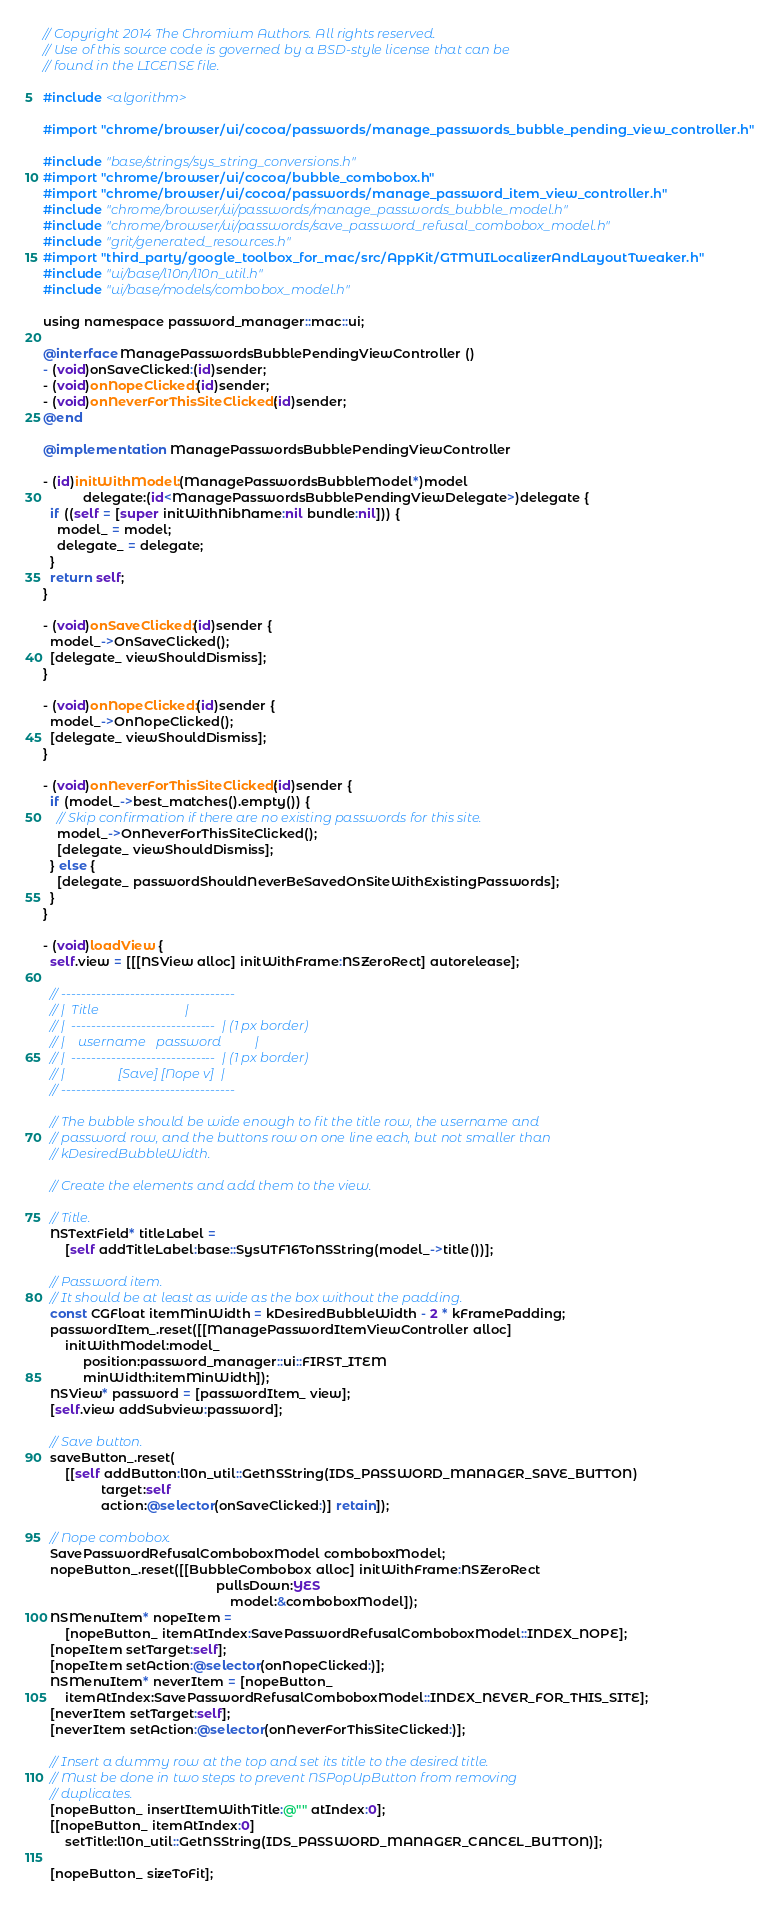<code> <loc_0><loc_0><loc_500><loc_500><_ObjectiveC_>// Copyright 2014 The Chromium Authors. All rights reserved.
// Use of this source code is governed by a BSD-style license that can be
// found in the LICENSE file.

#include <algorithm>

#import "chrome/browser/ui/cocoa/passwords/manage_passwords_bubble_pending_view_controller.h"

#include "base/strings/sys_string_conversions.h"
#import "chrome/browser/ui/cocoa/bubble_combobox.h"
#import "chrome/browser/ui/cocoa/passwords/manage_password_item_view_controller.h"
#include "chrome/browser/ui/passwords/manage_passwords_bubble_model.h"
#include "chrome/browser/ui/passwords/save_password_refusal_combobox_model.h"
#include "grit/generated_resources.h"
#import "third_party/google_toolbox_for_mac/src/AppKit/GTMUILocalizerAndLayoutTweaker.h"
#include "ui/base/l10n/l10n_util.h"
#include "ui/base/models/combobox_model.h"

using namespace password_manager::mac::ui;

@interface ManagePasswordsBubblePendingViewController ()
- (void)onSaveClicked:(id)sender;
- (void)onNopeClicked:(id)sender;
- (void)onNeverForThisSiteClicked:(id)sender;
@end

@implementation ManagePasswordsBubblePendingViewController

- (id)initWithModel:(ManagePasswordsBubbleModel*)model
           delegate:(id<ManagePasswordsBubblePendingViewDelegate>)delegate {
  if ((self = [super initWithNibName:nil bundle:nil])) {
    model_ = model;
    delegate_ = delegate;
  }
  return self;
}

- (void)onSaveClicked:(id)sender {
  model_->OnSaveClicked();
  [delegate_ viewShouldDismiss];
}

- (void)onNopeClicked:(id)sender {
  model_->OnNopeClicked();
  [delegate_ viewShouldDismiss];
}

- (void)onNeverForThisSiteClicked:(id)sender {
  if (model_->best_matches().empty()) {
    // Skip confirmation if there are no existing passwords for this site.
    model_->OnNeverForThisSiteClicked();
    [delegate_ viewShouldDismiss];
  } else {
    [delegate_ passwordShouldNeverBeSavedOnSiteWithExistingPasswords];
  }
}

- (void)loadView {
  self.view = [[[NSView alloc] initWithFrame:NSZeroRect] autorelease];

  // -----------------------------------
  // |  Title                          |
  // |  -----------------------------  | (1 px border)
  // |    username   password          |
  // |  -----------------------------  | (1 px border)
  // |                [Save] [Nope v]  |
  // -----------------------------------

  // The bubble should be wide enough to fit the title row, the username and
  // password row, and the buttons row on one line each, but not smaller than
  // kDesiredBubbleWidth.

  // Create the elements and add them to the view.

  // Title.
  NSTextField* titleLabel =
      [self addTitleLabel:base::SysUTF16ToNSString(model_->title())];

  // Password item.
  // It should be at least as wide as the box without the padding.
  const CGFloat itemMinWidth = kDesiredBubbleWidth - 2 * kFramePadding;
  passwordItem_.reset([[ManagePasswordItemViewController alloc]
      initWithModel:model_
           position:password_manager::ui::FIRST_ITEM
           minWidth:itemMinWidth]);
  NSView* password = [passwordItem_ view];
  [self.view addSubview:password];

  // Save button.
  saveButton_.reset(
      [[self addButton:l10n_util::GetNSString(IDS_PASSWORD_MANAGER_SAVE_BUTTON)
                target:self
                action:@selector(onSaveClicked:)] retain]);

  // Nope combobox.
  SavePasswordRefusalComboboxModel comboboxModel;
  nopeButton_.reset([[BubbleCombobox alloc] initWithFrame:NSZeroRect
                                                pullsDown:YES
                                                    model:&comboboxModel]);
  NSMenuItem* nopeItem =
      [nopeButton_ itemAtIndex:SavePasswordRefusalComboboxModel::INDEX_NOPE];
  [nopeItem setTarget:self];
  [nopeItem setAction:@selector(onNopeClicked:)];
  NSMenuItem* neverItem = [nopeButton_
      itemAtIndex:SavePasswordRefusalComboboxModel::INDEX_NEVER_FOR_THIS_SITE];
  [neverItem setTarget:self];
  [neverItem setAction:@selector(onNeverForThisSiteClicked:)];

  // Insert a dummy row at the top and set its title to the desired title.
  // Must be done in two steps to prevent NSPopUpButton from removing
  // duplicates.
  [nopeButton_ insertItemWithTitle:@"" atIndex:0];
  [[nopeButton_ itemAtIndex:0]
      setTitle:l10n_util::GetNSString(IDS_PASSWORD_MANAGER_CANCEL_BUTTON)];

  [nopeButton_ sizeToFit];</code> 